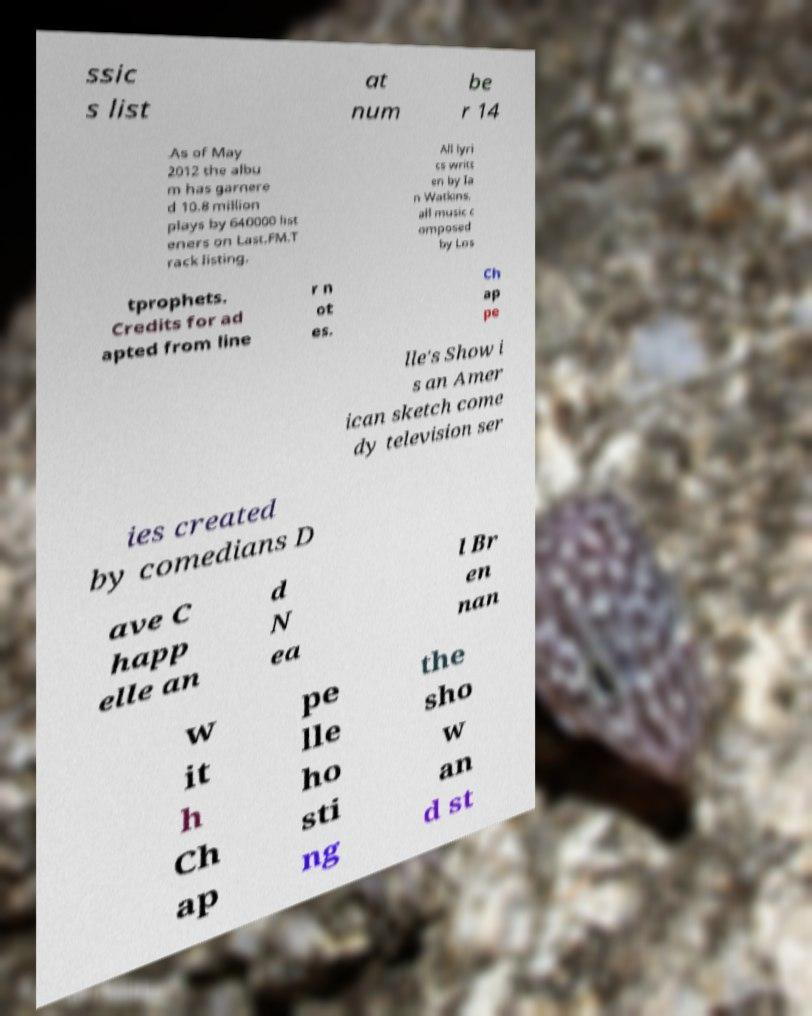What messages or text are displayed in this image? I need them in a readable, typed format. ssic s list at num be r 14 .As of May 2012 the albu m has garnere d 10.8 million plays by 640000 list eners on Last.FM.T rack listing. All lyri cs writt en by Ia n Watkins, all music c omposed by Los tprophets. Credits for ad apted from line r n ot es. Ch ap pe lle's Show i s an Amer ican sketch come dy television ser ies created by comedians D ave C happ elle an d N ea l Br en nan w it h Ch ap pe lle ho sti ng the sho w an d st 